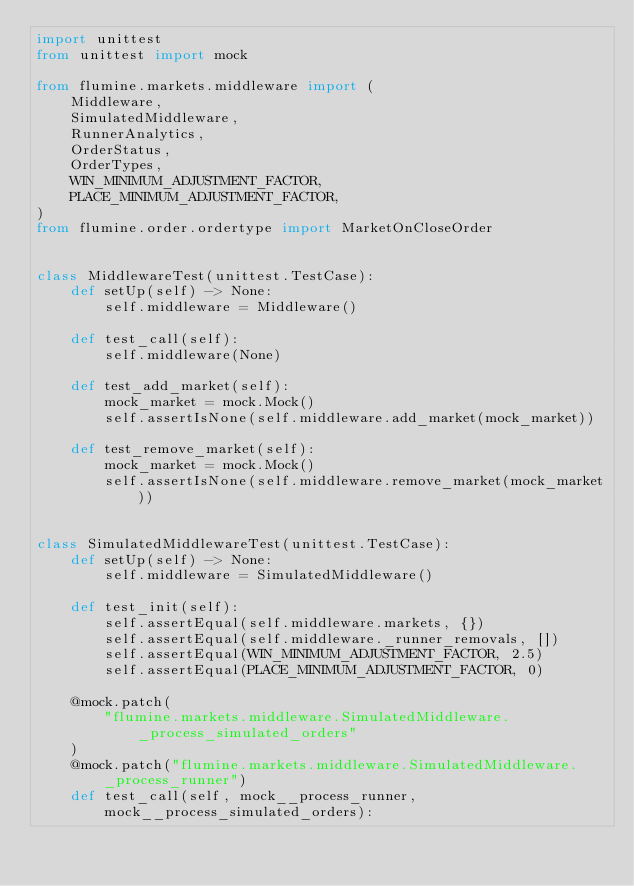<code> <loc_0><loc_0><loc_500><loc_500><_Python_>import unittest
from unittest import mock

from flumine.markets.middleware import (
    Middleware,
    SimulatedMiddleware,
    RunnerAnalytics,
    OrderStatus,
    OrderTypes,
    WIN_MINIMUM_ADJUSTMENT_FACTOR,
    PLACE_MINIMUM_ADJUSTMENT_FACTOR,
)
from flumine.order.ordertype import MarketOnCloseOrder


class MiddlewareTest(unittest.TestCase):
    def setUp(self) -> None:
        self.middleware = Middleware()

    def test_call(self):
        self.middleware(None)

    def test_add_market(self):
        mock_market = mock.Mock()
        self.assertIsNone(self.middleware.add_market(mock_market))

    def test_remove_market(self):
        mock_market = mock.Mock()
        self.assertIsNone(self.middleware.remove_market(mock_market))


class SimulatedMiddlewareTest(unittest.TestCase):
    def setUp(self) -> None:
        self.middleware = SimulatedMiddleware()

    def test_init(self):
        self.assertEqual(self.middleware.markets, {})
        self.assertEqual(self.middleware._runner_removals, [])
        self.assertEqual(WIN_MINIMUM_ADJUSTMENT_FACTOR, 2.5)
        self.assertEqual(PLACE_MINIMUM_ADJUSTMENT_FACTOR, 0)

    @mock.patch(
        "flumine.markets.middleware.SimulatedMiddleware._process_simulated_orders"
    )
    @mock.patch("flumine.markets.middleware.SimulatedMiddleware._process_runner")
    def test_call(self, mock__process_runner, mock__process_simulated_orders):</code> 